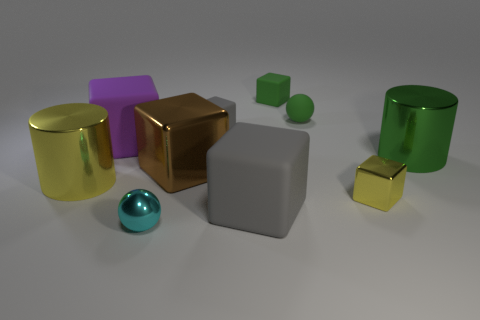Is the material of the purple cube the same as the tiny yellow cube?
Your response must be concise. No. How many purple blocks are the same material as the large green thing?
Provide a succinct answer. 0. What size is the yellow thing that is the same shape as the big green object?
Make the answer very short. Large. There is a gray object in front of the big green object; is it the same shape as the big purple object?
Offer a very short reply. Yes. There is a gray rubber object that is in front of the purple thing in front of the tiny green cube; what shape is it?
Your answer should be very brief. Cube. There is another large thing that is the same shape as the green metallic thing; what color is it?
Your answer should be compact. Yellow. Do the tiny matte sphere and the metallic cylinder that is on the right side of the tiny green rubber block have the same color?
Keep it short and to the point. Yes. There is a object that is to the left of the big green cylinder and on the right side of the rubber sphere; what shape is it?
Keep it short and to the point. Cube. Is the number of big brown blocks less than the number of small gray cylinders?
Offer a very short reply. No. Are there any big yellow metallic blocks?
Make the answer very short. No. 